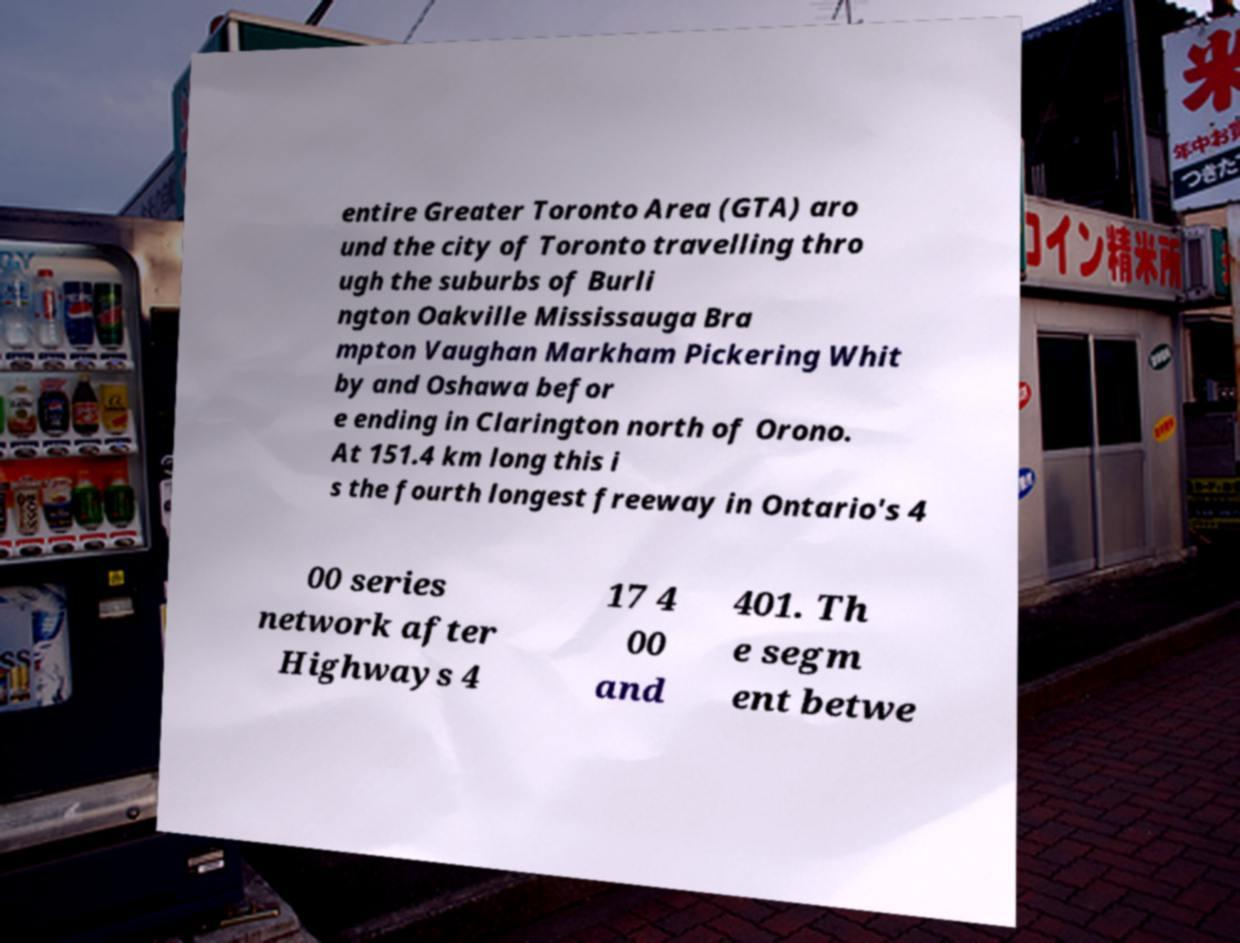Can you read and provide the text displayed in the image?This photo seems to have some interesting text. Can you extract and type it out for me? entire Greater Toronto Area (GTA) aro und the city of Toronto travelling thro ugh the suburbs of Burli ngton Oakville Mississauga Bra mpton Vaughan Markham Pickering Whit by and Oshawa befor e ending in Clarington north of Orono. At 151.4 km long this i s the fourth longest freeway in Ontario's 4 00 series network after Highways 4 17 4 00 and 401. Th e segm ent betwe 